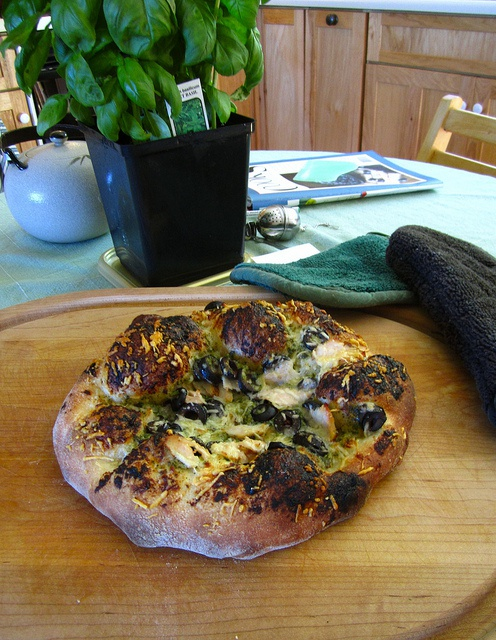Describe the objects in this image and their specific colors. I can see dining table in black, olive, tan, and gray tones, pizza in black, maroon, and olive tones, potted plant in black, darkgreen, teal, and darkblue tones, book in black, white, and lightblue tones, and chair in black, olive, and khaki tones in this image. 